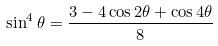<formula> <loc_0><loc_0><loc_500><loc_500>\sin ^ { 4 } \theta = \frac { 3 - 4 \cos 2 \theta + \cos 4 \theta } { 8 }</formula> 